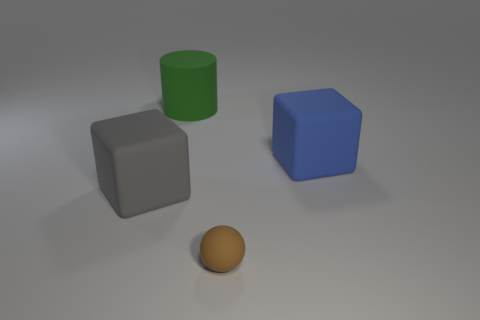There is a brown matte ball; does it have the same size as the block to the left of the large green rubber cylinder? no 